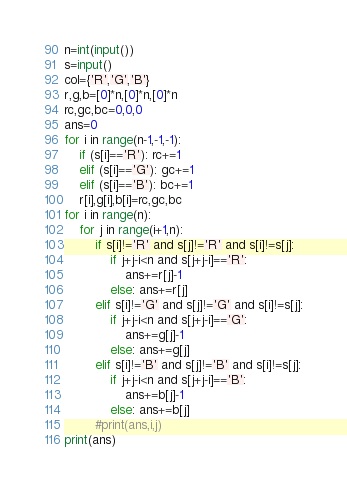<code> <loc_0><loc_0><loc_500><loc_500><_Python_>n=int(input())
s=input()
col={'R','G','B'}
r,g,b=[0]*n,[0]*n,[0]*n
rc,gc,bc=0,0,0
ans=0
for i in range(n-1,-1,-1):
    if (s[i]=='R'): rc+=1
    elif (s[i]=='G'): gc+=1
    elif (s[i]=='B'): bc+=1
    r[i],g[i],b[i]=rc,gc,bc
for i in range(n):
    for j in range(i+1,n):
        if s[i]!='R' and s[j]!='R' and s[i]!=s[j]:
            if j+j-i<n and s[j+j-i]=='R':
                ans+=r[j]-1
            else: ans+=r[j]
        elif s[i]!='G' and s[j]!='G' and s[i]!=s[j]:
            if j+j-i<n and s[j+j-i]=='G':
                ans+=g[j]-1
            else: ans+=g[j]
        elif s[i]!='B' and s[j]!='B' and s[i]!=s[j]:
            if j+j-i<n and s[j+j-i]=='B':
                ans+=b[j]-1
            else: ans+=b[j]
        #print(ans,i,j)
print(ans)
</code> 